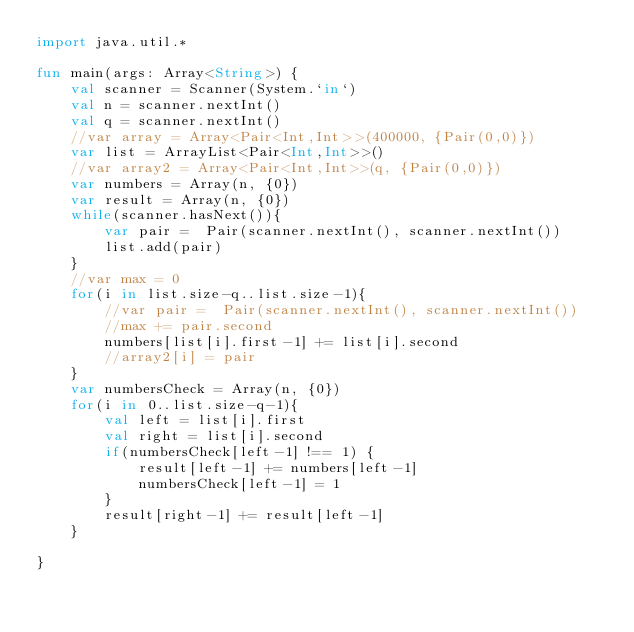Convert code to text. <code><loc_0><loc_0><loc_500><loc_500><_Kotlin_>import java.util.*

fun main(args: Array<String>) {
    val scanner = Scanner(System.`in`)
    val n = scanner.nextInt()
    val q = scanner.nextInt()
    //var array = Array<Pair<Int,Int>>(400000, {Pair(0,0)})
    var list = ArrayList<Pair<Int,Int>>()
    //var array2 = Array<Pair<Int,Int>>(q, {Pair(0,0)})
    var numbers = Array(n, {0})
    var result = Array(n, {0})
    while(scanner.hasNext()){
        var pair =  Pair(scanner.nextInt(), scanner.nextInt())
        list.add(pair)
    }
    //var max = 0
    for(i in list.size-q..list.size-1){
        //var pair =  Pair(scanner.nextInt(), scanner.nextInt())
        //max += pair.second
        numbers[list[i].first-1] += list[i].second
        //array2[i] = pair
    }
    var numbersCheck = Array(n, {0})
    for(i in 0..list.size-q-1){
        val left = list[i].first
        val right = list[i].second
        if(numbersCheck[left-1] !== 1) {
            result[left-1] += numbers[left-1]
            numbersCheck[left-1] = 1
        }
        result[right-1] += result[left-1]
    }

}</code> 